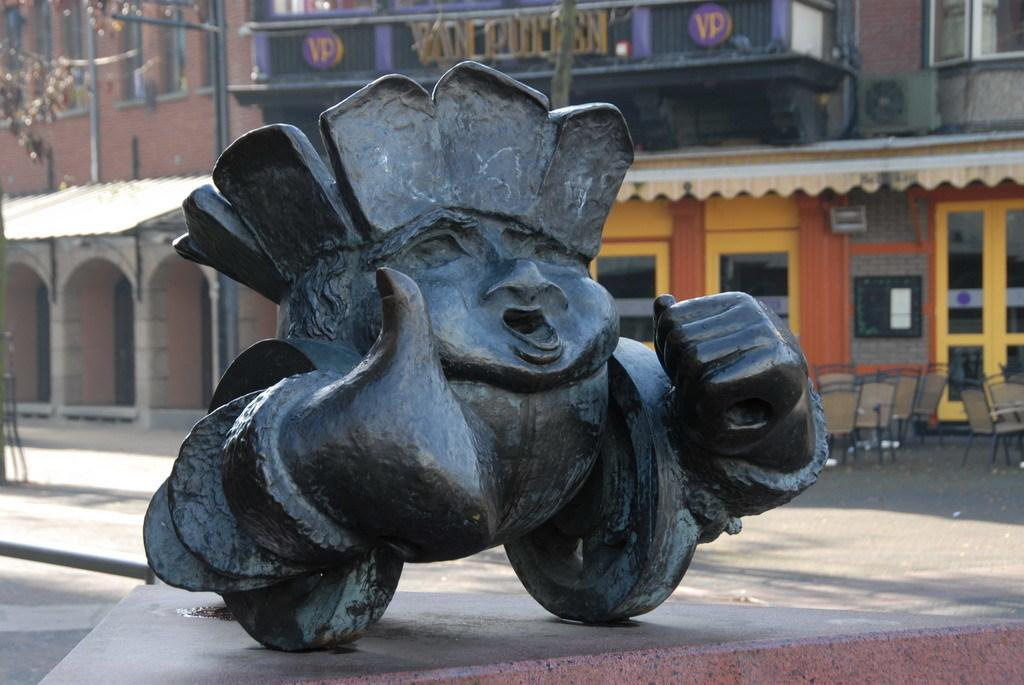What is the main subject of the image? There is a sculpture on a platform in the image. What can be seen in the background of the image? There are chairs, buildings with windows, sun shades, and some unspecified objects in the background of the image. Can you tell me how many grapes are on the sculpture in the image? There are no grapes present on the sculpture in the image. What country is depicted in the background of the image? The image does not depict a specific country; it only shows a sculpture, platform, and background elements. 